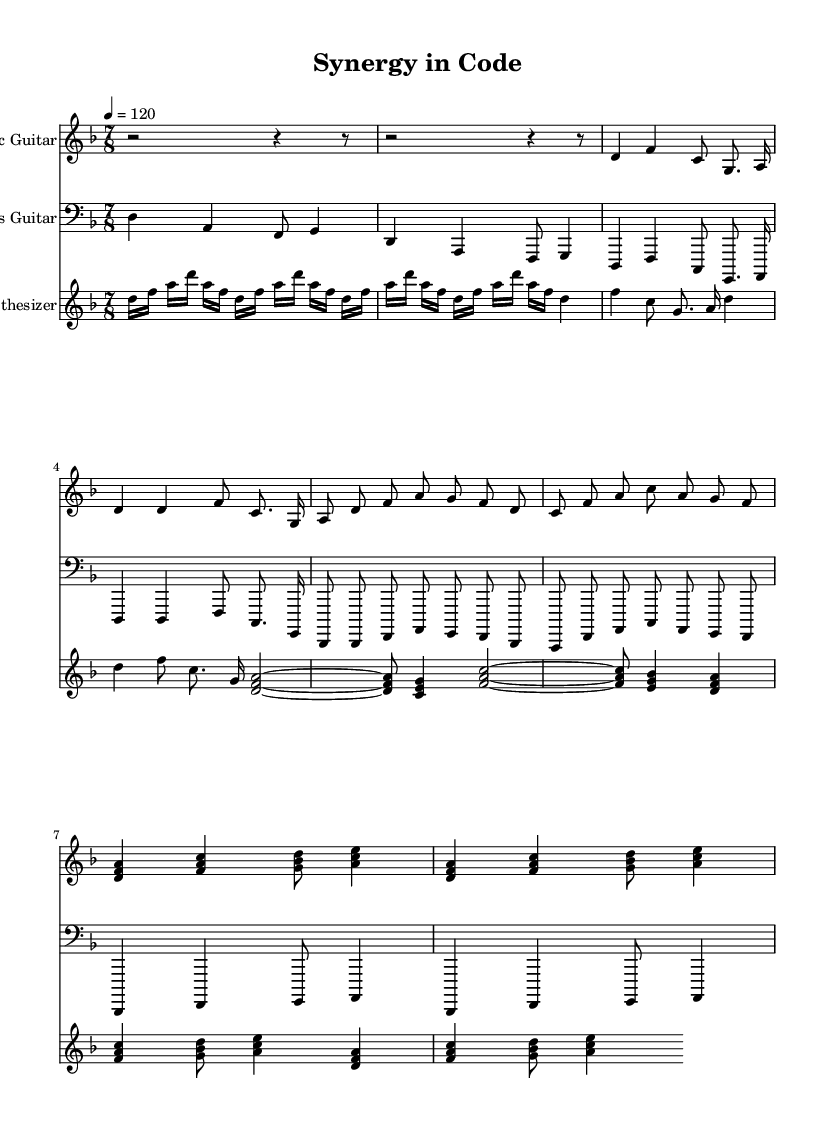What is the key signature of this music? The key signature is D minor, indicated by one flat (B flat), which is shown at the beginning of the score.
Answer: D minor What is the time signature of the piece? The time signature is 7/8, which allows for seven eighth-note beats in each measure, as indicated at the start of the score.
Answer: 7/8 What is the tempo marking for this music? The tempo marking is set to 120 beats per minute (quarter note), which is indicated in the top section of the score.
Answer: 120 How many measures are in the main riff section? The main riff section consists of 4 measures, which can be counted by identifying the separate groupings of notes between vertical bars (measure lines).
Answer: 4 What instruments are used in this piece? The instruments listed in the score include Electric Guitar, Bass Guitar, and Synthesizer, which are named at the beginning of each staff.
Answer: Electric Guitar, Bass Guitar, Synthesizer What type of structure does this piece have? The structure can be identified as having an Intro, Main riff, Verse, and Chorus, organizing the music into distinct sections, typical in progressive rock fusion.
Answer: Intro, Main riff, Verse, Chorus What characteristic pattern is present in the synthesizer part? The synthesizer part features an arpeggiated pattern in the intro, which is characterized by broken chords played in succession rather than simultaneously.
Answer: Arpeggiated pattern 